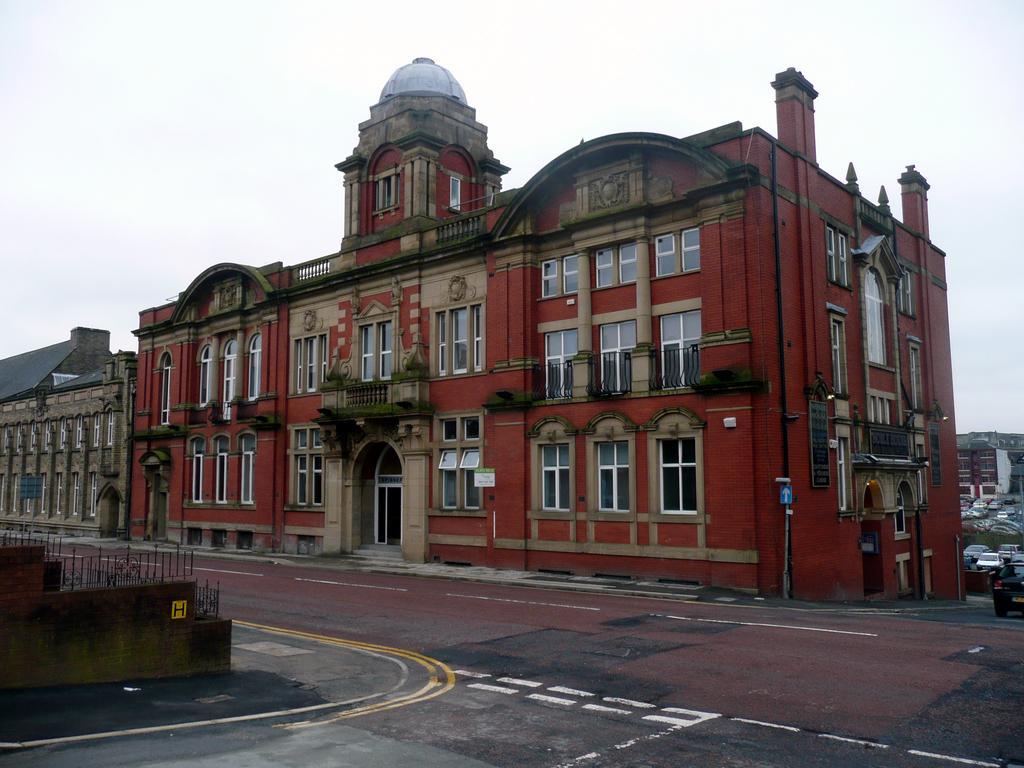Please provide a concise description of this image. In this image I can see the road. To the side of the road I can see the railing and the buildings with windows. I can see some boards to the building. In the background I can see the vehicles and the sky. 